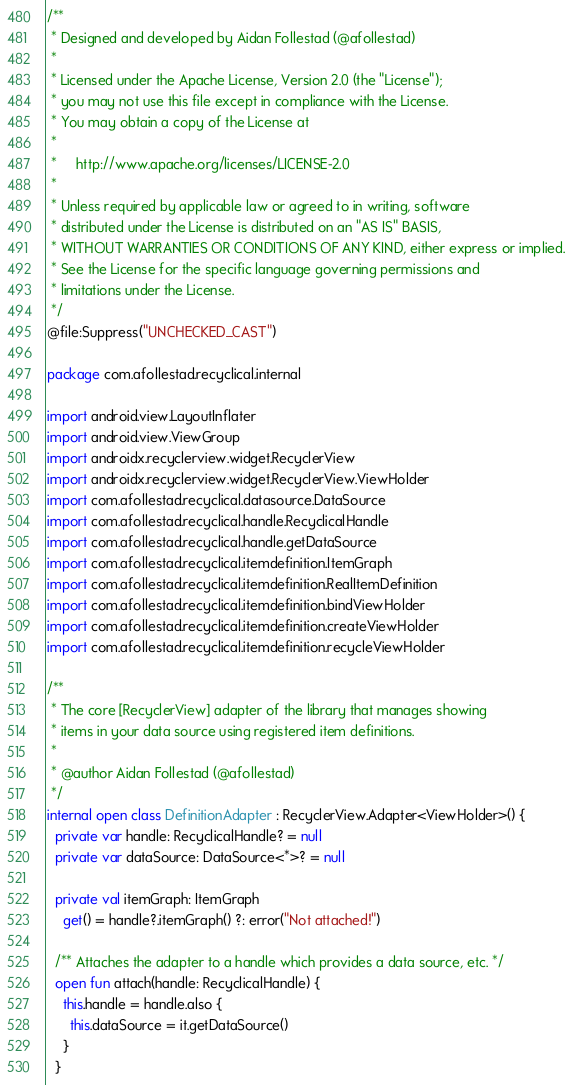Convert code to text. <code><loc_0><loc_0><loc_500><loc_500><_Kotlin_>/**
 * Designed and developed by Aidan Follestad (@afollestad)
 *
 * Licensed under the Apache License, Version 2.0 (the "License");
 * you may not use this file except in compliance with the License.
 * You may obtain a copy of the License at
 *
 *     http://www.apache.org/licenses/LICENSE-2.0
 *
 * Unless required by applicable law or agreed to in writing, software
 * distributed under the License is distributed on an "AS IS" BASIS,
 * WITHOUT WARRANTIES OR CONDITIONS OF ANY KIND, either express or implied.
 * See the License for the specific language governing permissions and
 * limitations under the License.
 */
@file:Suppress("UNCHECKED_CAST")

package com.afollestad.recyclical.internal

import android.view.LayoutInflater
import android.view.ViewGroup
import androidx.recyclerview.widget.RecyclerView
import androidx.recyclerview.widget.RecyclerView.ViewHolder
import com.afollestad.recyclical.datasource.DataSource
import com.afollestad.recyclical.handle.RecyclicalHandle
import com.afollestad.recyclical.handle.getDataSource
import com.afollestad.recyclical.itemdefinition.ItemGraph
import com.afollestad.recyclical.itemdefinition.RealItemDefinition
import com.afollestad.recyclical.itemdefinition.bindViewHolder
import com.afollestad.recyclical.itemdefinition.createViewHolder
import com.afollestad.recyclical.itemdefinition.recycleViewHolder

/**
 * The core [RecyclerView] adapter of the library that manages showing
 * items in your data source using registered item definitions.
 *
 * @author Aidan Follestad (@afollestad)
 */
internal open class DefinitionAdapter : RecyclerView.Adapter<ViewHolder>() {
  private var handle: RecyclicalHandle? = null
  private var dataSource: DataSource<*>? = null

  private val itemGraph: ItemGraph
    get() = handle?.itemGraph() ?: error("Not attached!")

  /** Attaches the adapter to a handle which provides a data source, etc. */
  open fun attach(handle: RecyclicalHandle) {
    this.handle = handle.also {
      this.dataSource = it.getDataSource()
    }
  }
</code> 